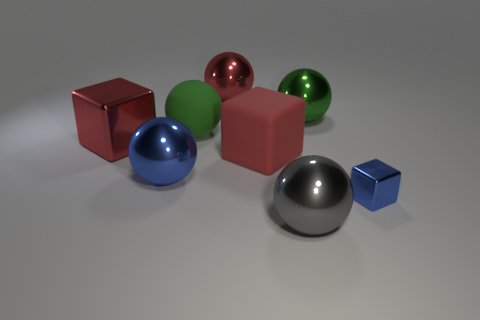What is the material of the other block that is the same color as the large metallic block?
Keep it short and to the point. Rubber. Is there anything else of the same color as the small thing?
Offer a very short reply. Yes. What shape is the red thing that is both in front of the big green metallic sphere and on the right side of the green rubber ball?
Offer a terse response. Cube. The large red metal thing that is behind the metal block that is to the left of the red metallic object behind the large green rubber sphere is what shape?
Provide a succinct answer. Sphere. There is a red thing that is both in front of the large rubber sphere and right of the big green rubber ball; what is its material?
Provide a succinct answer. Rubber. What number of red shiny blocks have the same size as the green shiny object?
Give a very brief answer. 1. How many shiny things are blue cubes or big gray things?
Keep it short and to the point. 2. What number of large green matte spheres are left of the tiny shiny thing?
Offer a very short reply. 1. Does the green ball left of the big green metal ball have the same material as the small thing?
Your answer should be compact. No. How many other big objects are the same shape as the big blue shiny thing?
Keep it short and to the point. 4. 